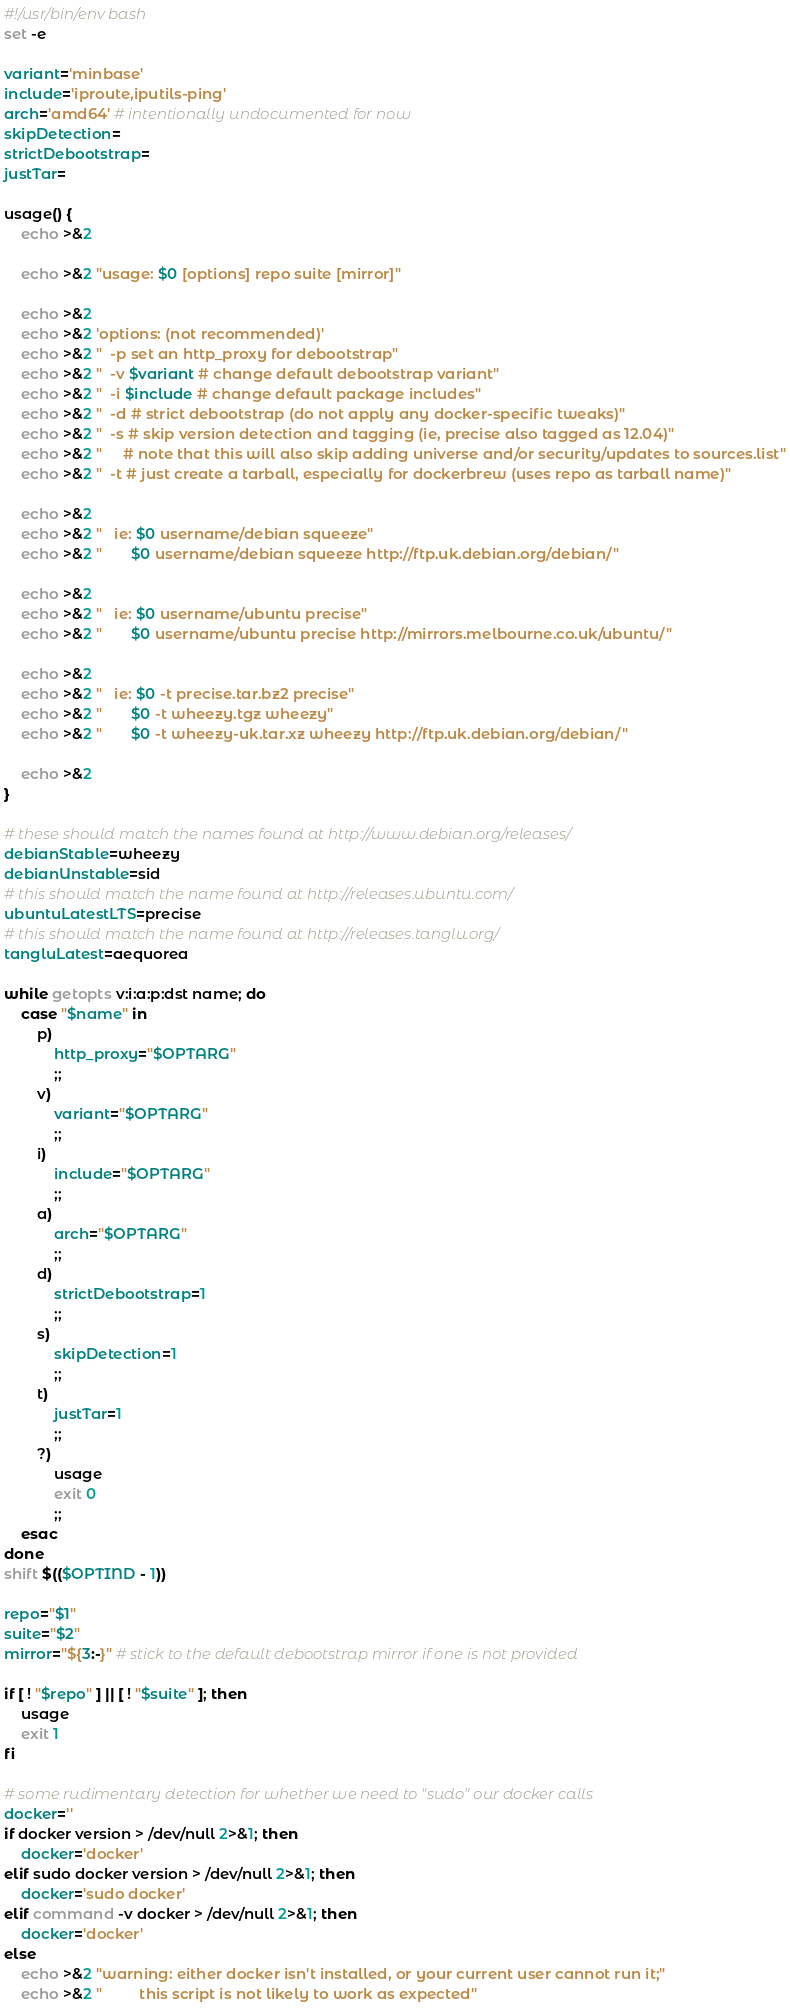Convert code to text. <code><loc_0><loc_0><loc_500><loc_500><_Bash_>#!/usr/bin/env bash
set -e

variant='minbase'
include='iproute,iputils-ping'
arch='amd64' # intentionally undocumented for now
skipDetection=
strictDebootstrap=
justTar=

usage() {
	echo >&2
	
	echo >&2 "usage: $0 [options] repo suite [mirror]"
	
	echo >&2
	echo >&2 'options: (not recommended)'
	echo >&2 "  -p set an http_proxy for debootstrap"
	echo >&2 "  -v $variant # change default debootstrap variant"
	echo >&2 "  -i $include # change default package includes"
	echo >&2 "  -d # strict debootstrap (do not apply any docker-specific tweaks)"
	echo >&2 "  -s # skip version detection and tagging (ie, precise also tagged as 12.04)"
	echo >&2 "     # note that this will also skip adding universe and/or security/updates to sources.list"
	echo >&2 "  -t # just create a tarball, especially for dockerbrew (uses repo as tarball name)"
	
	echo >&2
	echo >&2 "   ie: $0 username/debian squeeze"
	echo >&2 "       $0 username/debian squeeze http://ftp.uk.debian.org/debian/"
	
	echo >&2
	echo >&2 "   ie: $0 username/ubuntu precise"
	echo >&2 "       $0 username/ubuntu precise http://mirrors.melbourne.co.uk/ubuntu/"
	
	echo >&2
	echo >&2 "   ie: $0 -t precise.tar.bz2 precise"
	echo >&2 "       $0 -t wheezy.tgz wheezy"
	echo >&2 "       $0 -t wheezy-uk.tar.xz wheezy http://ftp.uk.debian.org/debian/"
	
	echo >&2
}

# these should match the names found at http://www.debian.org/releases/
debianStable=wheezy
debianUnstable=sid
# this should match the name found at http://releases.ubuntu.com/
ubuntuLatestLTS=precise
# this should match the name found at http://releases.tanglu.org/
tangluLatest=aequorea

while getopts v:i:a:p:dst name; do
	case "$name" in
		p)
			http_proxy="$OPTARG"
			;;
		v)
			variant="$OPTARG"
			;;
		i)
			include="$OPTARG"
			;;
		a)
			arch="$OPTARG"
			;;
		d)
			strictDebootstrap=1
			;;
		s)
			skipDetection=1
			;;
		t)
			justTar=1
			;;
		?)
			usage
			exit 0
			;;
	esac
done
shift $(($OPTIND - 1))

repo="$1"
suite="$2"
mirror="${3:-}" # stick to the default debootstrap mirror if one is not provided

if [ ! "$repo" ] || [ ! "$suite" ]; then
	usage
	exit 1
fi

# some rudimentary detection for whether we need to "sudo" our docker calls
docker=''
if docker version > /dev/null 2>&1; then
	docker='docker'
elif sudo docker version > /dev/null 2>&1; then
	docker='sudo docker'
elif command -v docker > /dev/null 2>&1; then
	docker='docker'
else
	echo >&2 "warning: either docker isn't installed, or your current user cannot run it;"
	echo >&2 "         this script is not likely to work as expected"</code> 